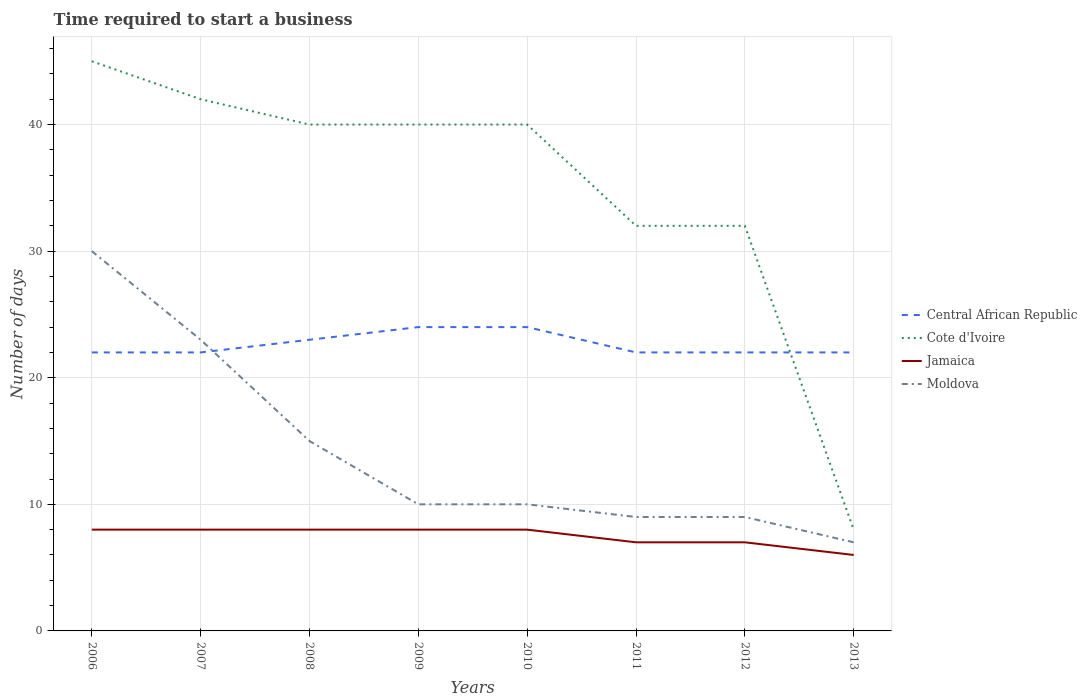Is the number of lines equal to the number of legend labels?
Make the answer very short. Yes. In which year was the number of days required to start a business in Moldova maximum?
Offer a very short reply. 2013. What is the total number of days required to start a business in Cote d'Ivoire in the graph?
Provide a short and direct response. 13. What is the difference between the highest and the second highest number of days required to start a business in Jamaica?
Make the answer very short. 2. What is the difference between the highest and the lowest number of days required to start a business in Jamaica?
Offer a terse response. 5. Is the number of days required to start a business in Moldova strictly greater than the number of days required to start a business in Central African Republic over the years?
Your answer should be compact. No. How many lines are there?
Your response must be concise. 4. How many years are there in the graph?
Keep it short and to the point. 8. What is the difference between two consecutive major ticks on the Y-axis?
Give a very brief answer. 10. How are the legend labels stacked?
Offer a terse response. Vertical. What is the title of the graph?
Provide a succinct answer. Time required to start a business. Does "Portugal" appear as one of the legend labels in the graph?
Offer a terse response. No. What is the label or title of the X-axis?
Give a very brief answer. Years. What is the label or title of the Y-axis?
Keep it short and to the point. Number of days. What is the Number of days in Cote d'Ivoire in 2006?
Your response must be concise. 45. What is the Number of days in Central African Republic in 2007?
Offer a very short reply. 22. What is the Number of days of Central African Republic in 2008?
Ensure brevity in your answer.  23. What is the Number of days of Cote d'Ivoire in 2008?
Your answer should be very brief. 40. What is the Number of days in Jamaica in 2008?
Your response must be concise. 8. What is the Number of days of Moldova in 2008?
Ensure brevity in your answer.  15. What is the Number of days of Central African Republic in 2009?
Your answer should be compact. 24. What is the Number of days in Central African Republic in 2010?
Offer a terse response. 24. What is the Number of days of Jamaica in 2010?
Your response must be concise. 8. What is the Number of days in Moldova in 2010?
Keep it short and to the point. 10. What is the Number of days in Central African Republic in 2012?
Your response must be concise. 22. What is the Number of days of Central African Republic in 2013?
Provide a succinct answer. 22. Across all years, what is the maximum Number of days of Cote d'Ivoire?
Make the answer very short. 45. Across all years, what is the minimum Number of days in Central African Republic?
Your response must be concise. 22. Across all years, what is the minimum Number of days of Cote d'Ivoire?
Provide a short and direct response. 8. Across all years, what is the minimum Number of days of Moldova?
Offer a terse response. 7. What is the total Number of days of Central African Republic in the graph?
Provide a succinct answer. 181. What is the total Number of days in Cote d'Ivoire in the graph?
Offer a very short reply. 279. What is the total Number of days of Moldova in the graph?
Make the answer very short. 113. What is the difference between the Number of days of Central African Republic in 2006 and that in 2007?
Make the answer very short. 0. What is the difference between the Number of days of Central African Republic in 2006 and that in 2008?
Offer a very short reply. -1. What is the difference between the Number of days in Jamaica in 2006 and that in 2008?
Your answer should be very brief. 0. What is the difference between the Number of days in Jamaica in 2006 and that in 2009?
Ensure brevity in your answer.  0. What is the difference between the Number of days in Moldova in 2006 and that in 2009?
Your answer should be compact. 20. What is the difference between the Number of days of Cote d'Ivoire in 2006 and that in 2010?
Provide a short and direct response. 5. What is the difference between the Number of days in Moldova in 2006 and that in 2010?
Provide a short and direct response. 20. What is the difference between the Number of days in Central African Republic in 2006 and that in 2011?
Give a very brief answer. 0. What is the difference between the Number of days of Cote d'Ivoire in 2006 and that in 2011?
Your response must be concise. 13. What is the difference between the Number of days in Moldova in 2006 and that in 2011?
Ensure brevity in your answer.  21. What is the difference between the Number of days of Moldova in 2006 and that in 2012?
Give a very brief answer. 21. What is the difference between the Number of days of Cote d'Ivoire in 2006 and that in 2013?
Offer a terse response. 37. What is the difference between the Number of days of Jamaica in 2006 and that in 2013?
Your answer should be very brief. 2. What is the difference between the Number of days of Moldova in 2006 and that in 2013?
Offer a very short reply. 23. What is the difference between the Number of days in Central African Republic in 2007 and that in 2008?
Keep it short and to the point. -1. What is the difference between the Number of days in Jamaica in 2007 and that in 2008?
Keep it short and to the point. 0. What is the difference between the Number of days in Moldova in 2007 and that in 2008?
Your answer should be very brief. 8. What is the difference between the Number of days in Cote d'Ivoire in 2007 and that in 2010?
Make the answer very short. 2. What is the difference between the Number of days in Moldova in 2007 and that in 2010?
Keep it short and to the point. 13. What is the difference between the Number of days in Cote d'Ivoire in 2007 and that in 2011?
Make the answer very short. 10. What is the difference between the Number of days in Jamaica in 2007 and that in 2011?
Provide a short and direct response. 1. What is the difference between the Number of days of Moldova in 2007 and that in 2011?
Provide a short and direct response. 14. What is the difference between the Number of days in Cote d'Ivoire in 2007 and that in 2012?
Offer a very short reply. 10. What is the difference between the Number of days of Jamaica in 2007 and that in 2012?
Your answer should be compact. 1. What is the difference between the Number of days of Cote d'Ivoire in 2007 and that in 2013?
Offer a very short reply. 34. What is the difference between the Number of days of Jamaica in 2007 and that in 2013?
Your response must be concise. 2. What is the difference between the Number of days in Central African Republic in 2008 and that in 2009?
Provide a succinct answer. -1. What is the difference between the Number of days of Jamaica in 2008 and that in 2009?
Provide a succinct answer. 0. What is the difference between the Number of days of Central African Republic in 2008 and that in 2010?
Your answer should be compact. -1. What is the difference between the Number of days of Jamaica in 2008 and that in 2010?
Provide a succinct answer. 0. What is the difference between the Number of days in Moldova in 2008 and that in 2010?
Your answer should be very brief. 5. What is the difference between the Number of days in Central African Republic in 2008 and that in 2011?
Give a very brief answer. 1. What is the difference between the Number of days of Moldova in 2008 and that in 2011?
Ensure brevity in your answer.  6. What is the difference between the Number of days of Cote d'Ivoire in 2008 and that in 2012?
Your response must be concise. 8. What is the difference between the Number of days in Central African Republic in 2008 and that in 2013?
Your answer should be very brief. 1. What is the difference between the Number of days in Cote d'Ivoire in 2008 and that in 2013?
Keep it short and to the point. 32. What is the difference between the Number of days in Jamaica in 2008 and that in 2013?
Your answer should be compact. 2. What is the difference between the Number of days in Moldova in 2008 and that in 2013?
Offer a terse response. 8. What is the difference between the Number of days in Cote d'Ivoire in 2009 and that in 2010?
Your answer should be compact. 0. What is the difference between the Number of days in Central African Republic in 2009 and that in 2011?
Your answer should be very brief. 2. What is the difference between the Number of days in Moldova in 2009 and that in 2011?
Make the answer very short. 1. What is the difference between the Number of days of Cote d'Ivoire in 2009 and that in 2012?
Provide a short and direct response. 8. What is the difference between the Number of days in Jamaica in 2009 and that in 2012?
Your answer should be compact. 1. What is the difference between the Number of days of Jamaica in 2009 and that in 2013?
Provide a short and direct response. 2. What is the difference between the Number of days of Moldova in 2009 and that in 2013?
Provide a succinct answer. 3. What is the difference between the Number of days of Moldova in 2010 and that in 2011?
Provide a succinct answer. 1. What is the difference between the Number of days of Moldova in 2010 and that in 2012?
Keep it short and to the point. 1. What is the difference between the Number of days in Jamaica in 2011 and that in 2012?
Provide a short and direct response. 0. What is the difference between the Number of days in Cote d'Ivoire in 2011 and that in 2013?
Your answer should be compact. 24. What is the difference between the Number of days in Jamaica in 2011 and that in 2013?
Your response must be concise. 1. What is the difference between the Number of days in Cote d'Ivoire in 2012 and that in 2013?
Provide a succinct answer. 24. What is the difference between the Number of days in Jamaica in 2012 and that in 2013?
Your answer should be very brief. 1. What is the difference between the Number of days in Moldova in 2012 and that in 2013?
Your response must be concise. 2. What is the difference between the Number of days in Central African Republic in 2006 and the Number of days in Cote d'Ivoire in 2007?
Make the answer very short. -20. What is the difference between the Number of days in Central African Republic in 2006 and the Number of days in Jamaica in 2007?
Keep it short and to the point. 14. What is the difference between the Number of days in Central African Republic in 2006 and the Number of days in Moldova in 2007?
Your answer should be compact. -1. What is the difference between the Number of days of Jamaica in 2006 and the Number of days of Moldova in 2007?
Offer a very short reply. -15. What is the difference between the Number of days in Central African Republic in 2006 and the Number of days in Cote d'Ivoire in 2008?
Ensure brevity in your answer.  -18. What is the difference between the Number of days of Central African Republic in 2006 and the Number of days of Moldova in 2008?
Ensure brevity in your answer.  7. What is the difference between the Number of days in Jamaica in 2006 and the Number of days in Moldova in 2008?
Provide a succinct answer. -7. What is the difference between the Number of days of Central African Republic in 2006 and the Number of days of Cote d'Ivoire in 2009?
Provide a succinct answer. -18. What is the difference between the Number of days in Central African Republic in 2006 and the Number of days in Moldova in 2009?
Ensure brevity in your answer.  12. What is the difference between the Number of days in Cote d'Ivoire in 2006 and the Number of days in Moldova in 2009?
Keep it short and to the point. 35. What is the difference between the Number of days of Jamaica in 2006 and the Number of days of Moldova in 2009?
Make the answer very short. -2. What is the difference between the Number of days in Central African Republic in 2006 and the Number of days in Jamaica in 2010?
Offer a terse response. 14. What is the difference between the Number of days of Cote d'Ivoire in 2006 and the Number of days of Moldova in 2010?
Give a very brief answer. 35. What is the difference between the Number of days in Jamaica in 2006 and the Number of days in Moldova in 2011?
Offer a terse response. -1. What is the difference between the Number of days of Cote d'Ivoire in 2006 and the Number of days of Moldova in 2012?
Make the answer very short. 36. What is the difference between the Number of days in Jamaica in 2006 and the Number of days in Moldova in 2013?
Your answer should be very brief. 1. What is the difference between the Number of days of Central African Republic in 2007 and the Number of days of Cote d'Ivoire in 2008?
Your response must be concise. -18. What is the difference between the Number of days in Central African Republic in 2007 and the Number of days in Jamaica in 2008?
Your response must be concise. 14. What is the difference between the Number of days in Central African Republic in 2007 and the Number of days in Moldova in 2008?
Your answer should be compact. 7. What is the difference between the Number of days in Cote d'Ivoire in 2007 and the Number of days in Moldova in 2008?
Make the answer very short. 27. What is the difference between the Number of days in Central African Republic in 2007 and the Number of days in Cote d'Ivoire in 2009?
Make the answer very short. -18. What is the difference between the Number of days of Cote d'Ivoire in 2007 and the Number of days of Jamaica in 2009?
Offer a very short reply. 34. What is the difference between the Number of days in Cote d'Ivoire in 2007 and the Number of days in Moldova in 2009?
Ensure brevity in your answer.  32. What is the difference between the Number of days in Central African Republic in 2007 and the Number of days in Moldova in 2010?
Offer a very short reply. 12. What is the difference between the Number of days in Cote d'Ivoire in 2007 and the Number of days in Jamaica in 2010?
Give a very brief answer. 34. What is the difference between the Number of days in Cote d'Ivoire in 2007 and the Number of days in Moldova in 2010?
Your answer should be compact. 32. What is the difference between the Number of days in Central African Republic in 2007 and the Number of days in Jamaica in 2011?
Make the answer very short. 15. What is the difference between the Number of days in Cote d'Ivoire in 2007 and the Number of days in Jamaica in 2011?
Your response must be concise. 35. What is the difference between the Number of days in Cote d'Ivoire in 2007 and the Number of days in Moldova in 2011?
Your answer should be very brief. 33. What is the difference between the Number of days in Central African Republic in 2007 and the Number of days in Moldova in 2012?
Offer a very short reply. 13. What is the difference between the Number of days in Central African Republic in 2007 and the Number of days in Cote d'Ivoire in 2013?
Your answer should be compact. 14. What is the difference between the Number of days in Cote d'Ivoire in 2007 and the Number of days in Jamaica in 2013?
Offer a terse response. 36. What is the difference between the Number of days in Cote d'Ivoire in 2007 and the Number of days in Moldova in 2013?
Ensure brevity in your answer.  35. What is the difference between the Number of days in Central African Republic in 2008 and the Number of days in Cote d'Ivoire in 2009?
Your response must be concise. -17. What is the difference between the Number of days of Jamaica in 2008 and the Number of days of Moldova in 2009?
Make the answer very short. -2. What is the difference between the Number of days of Central African Republic in 2008 and the Number of days of Moldova in 2010?
Keep it short and to the point. 13. What is the difference between the Number of days of Jamaica in 2008 and the Number of days of Moldova in 2010?
Ensure brevity in your answer.  -2. What is the difference between the Number of days of Central African Republic in 2008 and the Number of days of Jamaica in 2011?
Give a very brief answer. 16. What is the difference between the Number of days in Cote d'Ivoire in 2008 and the Number of days in Jamaica in 2011?
Offer a terse response. 33. What is the difference between the Number of days of Cote d'Ivoire in 2008 and the Number of days of Moldova in 2011?
Ensure brevity in your answer.  31. What is the difference between the Number of days of Jamaica in 2008 and the Number of days of Moldova in 2011?
Provide a short and direct response. -1. What is the difference between the Number of days of Central African Republic in 2008 and the Number of days of Cote d'Ivoire in 2012?
Provide a short and direct response. -9. What is the difference between the Number of days of Central African Republic in 2008 and the Number of days of Jamaica in 2012?
Keep it short and to the point. 16. What is the difference between the Number of days in Cote d'Ivoire in 2008 and the Number of days in Jamaica in 2012?
Provide a succinct answer. 33. What is the difference between the Number of days of Central African Republic in 2008 and the Number of days of Cote d'Ivoire in 2013?
Offer a very short reply. 15. What is the difference between the Number of days of Central African Republic in 2008 and the Number of days of Moldova in 2013?
Ensure brevity in your answer.  16. What is the difference between the Number of days in Cote d'Ivoire in 2008 and the Number of days in Jamaica in 2013?
Offer a very short reply. 34. What is the difference between the Number of days in Jamaica in 2008 and the Number of days in Moldova in 2013?
Provide a short and direct response. 1. What is the difference between the Number of days in Central African Republic in 2009 and the Number of days in Cote d'Ivoire in 2010?
Provide a short and direct response. -16. What is the difference between the Number of days in Central African Republic in 2009 and the Number of days in Jamaica in 2010?
Make the answer very short. 16. What is the difference between the Number of days of Central African Republic in 2009 and the Number of days of Moldova in 2010?
Your answer should be compact. 14. What is the difference between the Number of days in Cote d'Ivoire in 2009 and the Number of days in Jamaica in 2010?
Keep it short and to the point. 32. What is the difference between the Number of days in Cote d'Ivoire in 2009 and the Number of days in Moldova in 2011?
Offer a very short reply. 31. What is the difference between the Number of days in Jamaica in 2009 and the Number of days in Moldova in 2011?
Your answer should be very brief. -1. What is the difference between the Number of days of Central African Republic in 2009 and the Number of days of Jamaica in 2012?
Your answer should be very brief. 17. What is the difference between the Number of days in Central African Republic in 2009 and the Number of days in Moldova in 2012?
Your answer should be very brief. 15. What is the difference between the Number of days of Cote d'Ivoire in 2009 and the Number of days of Jamaica in 2012?
Keep it short and to the point. 33. What is the difference between the Number of days in Cote d'Ivoire in 2009 and the Number of days in Moldova in 2012?
Provide a short and direct response. 31. What is the difference between the Number of days in Jamaica in 2009 and the Number of days in Moldova in 2012?
Keep it short and to the point. -1. What is the difference between the Number of days of Cote d'Ivoire in 2009 and the Number of days of Jamaica in 2013?
Keep it short and to the point. 34. What is the difference between the Number of days in Jamaica in 2009 and the Number of days in Moldova in 2013?
Your answer should be very brief. 1. What is the difference between the Number of days in Central African Republic in 2010 and the Number of days in Jamaica in 2011?
Give a very brief answer. 17. What is the difference between the Number of days in Central African Republic in 2010 and the Number of days in Moldova in 2011?
Offer a very short reply. 15. What is the difference between the Number of days of Cote d'Ivoire in 2010 and the Number of days of Jamaica in 2011?
Keep it short and to the point. 33. What is the difference between the Number of days in Cote d'Ivoire in 2010 and the Number of days in Moldova in 2011?
Offer a very short reply. 31. What is the difference between the Number of days of Jamaica in 2010 and the Number of days of Moldova in 2011?
Make the answer very short. -1. What is the difference between the Number of days of Central African Republic in 2010 and the Number of days of Moldova in 2012?
Your response must be concise. 15. What is the difference between the Number of days of Jamaica in 2010 and the Number of days of Moldova in 2012?
Offer a very short reply. -1. What is the difference between the Number of days in Central African Republic in 2010 and the Number of days in Cote d'Ivoire in 2013?
Your answer should be very brief. 16. What is the difference between the Number of days of Central African Republic in 2010 and the Number of days of Jamaica in 2013?
Make the answer very short. 18. What is the difference between the Number of days of Central African Republic in 2010 and the Number of days of Moldova in 2013?
Offer a terse response. 17. What is the difference between the Number of days of Cote d'Ivoire in 2010 and the Number of days of Jamaica in 2013?
Provide a succinct answer. 34. What is the difference between the Number of days in Central African Republic in 2011 and the Number of days in Jamaica in 2012?
Ensure brevity in your answer.  15. What is the difference between the Number of days in Cote d'Ivoire in 2011 and the Number of days in Moldova in 2012?
Ensure brevity in your answer.  23. What is the difference between the Number of days of Jamaica in 2011 and the Number of days of Moldova in 2012?
Your response must be concise. -2. What is the difference between the Number of days of Central African Republic in 2011 and the Number of days of Cote d'Ivoire in 2013?
Your answer should be compact. 14. What is the difference between the Number of days of Central African Republic in 2011 and the Number of days of Moldova in 2013?
Your response must be concise. 15. What is the difference between the Number of days in Cote d'Ivoire in 2011 and the Number of days in Jamaica in 2013?
Offer a very short reply. 26. What is the difference between the Number of days in Cote d'Ivoire in 2011 and the Number of days in Moldova in 2013?
Give a very brief answer. 25. What is the difference between the Number of days in Jamaica in 2011 and the Number of days in Moldova in 2013?
Make the answer very short. 0. What is the difference between the Number of days in Central African Republic in 2012 and the Number of days in Cote d'Ivoire in 2013?
Offer a terse response. 14. What is the difference between the Number of days in Central African Republic in 2012 and the Number of days in Jamaica in 2013?
Make the answer very short. 16. What is the difference between the Number of days in Central African Republic in 2012 and the Number of days in Moldova in 2013?
Offer a very short reply. 15. What is the difference between the Number of days in Cote d'Ivoire in 2012 and the Number of days in Jamaica in 2013?
Make the answer very short. 26. What is the average Number of days of Central African Republic per year?
Keep it short and to the point. 22.62. What is the average Number of days in Cote d'Ivoire per year?
Provide a succinct answer. 34.88. What is the average Number of days of Jamaica per year?
Ensure brevity in your answer.  7.5. What is the average Number of days in Moldova per year?
Ensure brevity in your answer.  14.12. In the year 2006, what is the difference between the Number of days of Jamaica and Number of days of Moldova?
Offer a very short reply. -22. In the year 2007, what is the difference between the Number of days of Central African Republic and Number of days of Jamaica?
Offer a very short reply. 14. In the year 2007, what is the difference between the Number of days in Central African Republic and Number of days in Moldova?
Offer a terse response. -1. In the year 2007, what is the difference between the Number of days in Cote d'Ivoire and Number of days in Moldova?
Your answer should be compact. 19. In the year 2007, what is the difference between the Number of days of Jamaica and Number of days of Moldova?
Offer a very short reply. -15. In the year 2008, what is the difference between the Number of days of Central African Republic and Number of days of Cote d'Ivoire?
Offer a very short reply. -17. In the year 2008, what is the difference between the Number of days in Central African Republic and Number of days in Jamaica?
Offer a terse response. 15. In the year 2008, what is the difference between the Number of days of Central African Republic and Number of days of Moldova?
Your answer should be very brief. 8. In the year 2008, what is the difference between the Number of days in Cote d'Ivoire and Number of days in Jamaica?
Make the answer very short. 32. In the year 2008, what is the difference between the Number of days of Jamaica and Number of days of Moldova?
Keep it short and to the point. -7. In the year 2009, what is the difference between the Number of days in Central African Republic and Number of days in Moldova?
Offer a very short reply. 14. In the year 2009, what is the difference between the Number of days in Cote d'Ivoire and Number of days in Moldova?
Provide a short and direct response. 30. In the year 2009, what is the difference between the Number of days in Jamaica and Number of days in Moldova?
Provide a succinct answer. -2. In the year 2010, what is the difference between the Number of days in Central African Republic and Number of days in Cote d'Ivoire?
Ensure brevity in your answer.  -16. In the year 2010, what is the difference between the Number of days of Central African Republic and Number of days of Jamaica?
Ensure brevity in your answer.  16. In the year 2010, what is the difference between the Number of days of Cote d'Ivoire and Number of days of Jamaica?
Offer a very short reply. 32. In the year 2011, what is the difference between the Number of days of Central African Republic and Number of days of Cote d'Ivoire?
Keep it short and to the point. -10. In the year 2011, what is the difference between the Number of days of Jamaica and Number of days of Moldova?
Your answer should be compact. -2. In the year 2012, what is the difference between the Number of days in Central African Republic and Number of days in Cote d'Ivoire?
Give a very brief answer. -10. In the year 2012, what is the difference between the Number of days in Central African Republic and Number of days in Jamaica?
Your response must be concise. 15. In the year 2012, what is the difference between the Number of days in Cote d'Ivoire and Number of days in Jamaica?
Provide a succinct answer. 25. In the year 2013, what is the difference between the Number of days in Central African Republic and Number of days in Jamaica?
Make the answer very short. 16. In the year 2013, what is the difference between the Number of days of Central African Republic and Number of days of Moldova?
Your answer should be very brief. 15. In the year 2013, what is the difference between the Number of days of Jamaica and Number of days of Moldova?
Your answer should be compact. -1. What is the ratio of the Number of days of Central African Republic in 2006 to that in 2007?
Give a very brief answer. 1. What is the ratio of the Number of days in Cote d'Ivoire in 2006 to that in 2007?
Offer a very short reply. 1.07. What is the ratio of the Number of days of Jamaica in 2006 to that in 2007?
Your answer should be compact. 1. What is the ratio of the Number of days in Moldova in 2006 to that in 2007?
Ensure brevity in your answer.  1.3. What is the ratio of the Number of days of Central African Republic in 2006 to that in 2008?
Provide a succinct answer. 0.96. What is the ratio of the Number of days of Cote d'Ivoire in 2006 to that in 2008?
Offer a very short reply. 1.12. What is the ratio of the Number of days of Central African Republic in 2006 to that in 2009?
Your answer should be compact. 0.92. What is the ratio of the Number of days in Jamaica in 2006 to that in 2009?
Your answer should be compact. 1. What is the ratio of the Number of days in Central African Republic in 2006 to that in 2010?
Offer a very short reply. 0.92. What is the ratio of the Number of days in Moldova in 2006 to that in 2010?
Offer a terse response. 3. What is the ratio of the Number of days in Central African Republic in 2006 to that in 2011?
Offer a very short reply. 1. What is the ratio of the Number of days of Cote d'Ivoire in 2006 to that in 2011?
Ensure brevity in your answer.  1.41. What is the ratio of the Number of days of Jamaica in 2006 to that in 2011?
Offer a very short reply. 1.14. What is the ratio of the Number of days of Moldova in 2006 to that in 2011?
Offer a very short reply. 3.33. What is the ratio of the Number of days in Cote d'Ivoire in 2006 to that in 2012?
Your response must be concise. 1.41. What is the ratio of the Number of days of Moldova in 2006 to that in 2012?
Make the answer very short. 3.33. What is the ratio of the Number of days of Central African Republic in 2006 to that in 2013?
Provide a succinct answer. 1. What is the ratio of the Number of days in Cote d'Ivoire in 2006 to that in 2013?
Give a very brief answer. 5.62. What is the ratio of the Number of days in Jamaica in 2006 to that in 2013?
Provide a short and direct response. 1.33. What is the ratio of the Number of days of Moldova in 2006 to that in 2013?
Keep it short and to the point. 4.29. What is the ratio of the Number of days in Central African Republic in 2007 to that in 2008?
Your response must be concise. 0.96. What is the ratio of the Number of days in Jamaica in 2007 to that in 2008?
Offer a very short reply. 1. What is the ratio of the Number of days of Moldova in 2007 to that in 2008?
Offer a very short reply. 1.53. What is the ratio of the Number of days of Central African Republic in 2007 to that in 2009?
Keep it short and to the point. 0.92. What is the ratio of the Number of days in Jamaica in 2007 to that in 2009?
Provide a short and direct response. 1. What is the ratio of the Number of days of Moldova in 2007 to that in 2009?
Keep it short and to the point. 2.3. What is the ratio of the Number of days of Cote d'Ivoire in 2007 to that in 2010?
Your answer should be compact. 1.05. What is the ratio of the Number of days in Moldova in 2007 to that in 2010?
Provide a short and direct response. 2.3. What is the ratio of the Number of days of Cote d'Ivoire in 2007 to that in 2011?
Your answer should be compact. 1.31. What is the ratio of the Number of days in Jamaica in 2007 to that in 2011?
Your answer should be very brief. 1.14. What is the ratio of the Number of days in Moldova in 2007 to that in 2011?
Provide a succinct answer. 2.56. What is the ratio of the Number of days in Central African Republic in 2007 to that in 2012?
Provide a succinct answer. 1. What is the ratio of the Number of days in Cote d'Ivoire in 2007 to that in 2012?
Ensure brevity in your answer.  1.31. What is the ratio of the Number of days of Moldova in 2007 to that in 2012?
Offer a terse response. 2.56. What is the ratio of the Number of days of Central African Republic in 2007 to that in 2013?
Give a very brief answer. 1. What is the ratio of the Number of days of Cote d'Ivoire in 2007 to that in 2013?
Provide a short and direct response. 5.25. What is the ratio of the Number of days of Moldova in 2007 to that in 2013?
Your answer should be compact. 3.29. What is the ratio of the Number of days in Cote d'Ivoire in 2008 to that in 2009?
Give a very brief answer. 1. What is the ratio of the Number of days in Central African Republic in 2008 to that in 2011?
Offer a very short reply. 1.05. What is the ratio of the Number of days in Cote d'Ivoire in 2008 to that in 2011?
Your answer should be very brief. 1.25. What is the ratio of the Number of days in Central African Republic in 2008 to that in 2012?
Your answer should be very brief. 1.05. What is the ratio of the Number of days in Cote d'Ivoire in 2008 to that in 2012?
Provide a short and direct response. 1.25. What is the ratio of the Number of days of Moldova in 2008 to that in 2012?
Offer a very short reply. 1.67. What is the ratio of the Number of days of Central African Republic in 2008 to that in 2013?
Keep it short and to the point. 1.05. What is the ratio of the Number of days in Jamaica in 2008 to that in 2013?
Give a very brief answer. 1.33. What is the ratio of the Number of days in Moldova in 2008 to that in 2013?
Offer a very short reply. 2.14. What is the ratio of the Number of days of Cote d'Ivoire in 2009 to that in 2010?
Provide a short and direct response. 1. What is the ratio of the Number of days of Moldova in 2009 to that in 2010?
Ensure brevity in your answer.  1. What is the ratio of the Number of days of Central African Republic in 2009 to that in 2011?
Provide a succinct answer. 1.09. What is the ratio of the Number of days in Cote d'Ivoire in 2009 to that in 2011?
Your response must be concise. 1.25. What is the ratio of the Number of days in Moldova in 2009 to that in 2011?
Provide a succinct answer. 1.11. What is the ratio of the Number of days in Central African Republic in 2009 to that in 2012?
Offer a terse response. 1.09. What is the ratio of the Number of days of Cote d'Ivoire in 2009 to that in 2012?
Give a very brief answer. 1.25. What is the ratio of the Number of days in Jamaica in 2009 to that in 2012?
Your answer should be very brief. 1.14. What is the ratio of the Number of days of Moldova in 2009 to that in 2013?
Make the answer very short. 1.43. What is the ratio of the Number of days of Cote d'Ivoire in 2010 to that in 2011?
Make the answer very short. 1.25. What is the ratio of the Number of days of Jamaica in 2010 to that in 2011?
Your answer should be compact. 1.14. What is the ratio of the Number of days of Moldova in 2010 to that in 2011?
Keep it short and to the point. 1.11. What is the ratio of the Number of days of Central African Republic in 2010 to that in 2012?
Offer a terse response. 1.09. What is the ratio of the Number of days of Cote d'Ivoire in 2010 to that in 2013?
Your answer should be very brief. 5. What is the ratio of the Number of days in Moldova in 2010 to that in 2013?
Make the answer very short. 1.43. What is the ratio of the Number of days of Central African Republic in 2011 to that in 2012?
Ensure brevity in your answer.  1. What is the ratio of the Number of days in Cote d'Ivoire in 2011 to that in 2012?
Your response must be concise. 1. What is the ratio of the Number of days in Jamaica in 2011 to that in 2012?
Your answer should be very brief. 1. What is the ratio of the Number of days in Jamaica in 2011 to that in 2013?
Give a very brief answer. 1.17. What is the ratio of the Number of days in Cote d'Ivoire in 2012 to that in 2013?
Your answer should be very brief. 4. What is the ratio of the Number of days in Moldova in 2012 to that in 2013?
Make the answer very short. 1.29. What is the difference between the highest and the second highest Number of days of Moldova?
Offer a terse response. 7. 